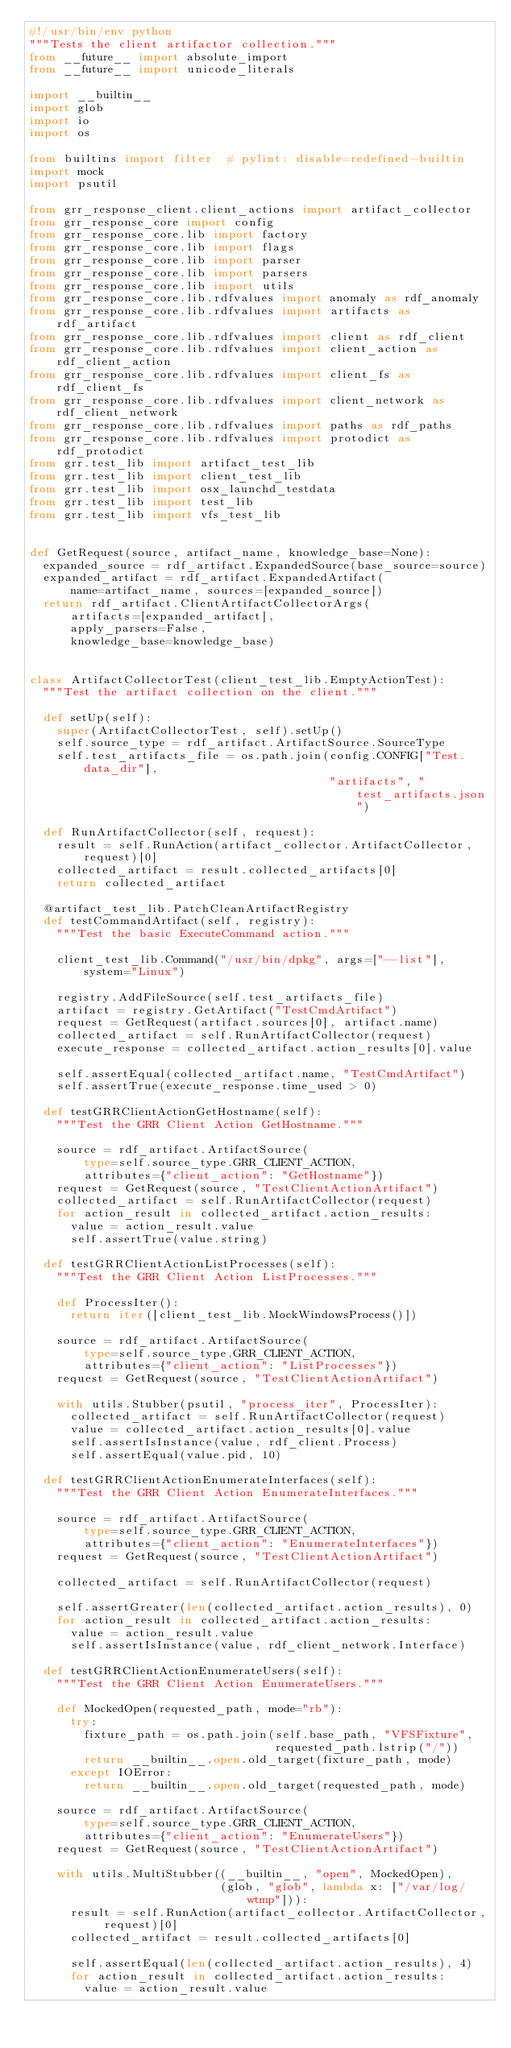Convert code to text. <code><loc_0><loc_0><loc_500><loc_500><_Python_>#!/usr/bin/env python
"""Tests the client artifactor collection."""
from __future__ import absolute_import
from __future__ import unicode_literals

import __builtin__
import glob
import io
import os

from builtins import filter  # pylint: disable=redefined-builtin
import mock
import psutil

from grr_response_client.client_actions import artifact_collector
from grr_response_core import config
from grr_response_core.lib import factory
from grr_response_core.lib import flags
from grr_response_core.lib import parser
from grr_response_core.lib import parsers
from grr_response_core.lib import utils
from grr_response_core.lib.rdfvalues import anomaly as rdf_anomaly
from grr_response_core.lib.rdfvalues import artifacts as rdf_artifact
from grr_response_core.lib.rdfvalues import client as rdf_client
from grr_response_core.lib.rdfvalues import client_action as rdf_client_action
from grr_response_core.lib.rdfvalues import client_fs as rdf_client_fs
from grr_response_core.lib.rdfvalues import client_network as rdf_client_network
from grr_response_core.lib.rdfvalues import paths as rdf_paths
from grr_response_core.lib.rdfvalues import protodict as rdf_protodict
from grr.test_lib import artifact_test_lib
from grr.test_lib import client_test_lib
from grr.test_lib import osx_launchd_testdata
from grr.test_lib import test_lib
from grr.test_lib import vfs_test_lib


def GetRequest(source, artifact_name, knowledge_base=None):
  expanded_source = rdf_artifact.ExpandedSource(base_source=source)
  expanded_artifact = rdf_artifact.ExpandedArtifact(
      name=artifact_name, sources=[expanded_source])
  return rdf_artifact.ClientArtifactCollectorArgs(
      artifacts=[expanded_artifact],
      apply_parsers=False,
      knowledge_base=knowledge_base)


class ArtifactCollectorTest(client_test_lib.EmptyActionTest):
  """Test the artifact collection on the client."""

  def setUp(self):
    super(ArtifactCollectorTest, self).setUp()
    self.source_type = rdf_artifact.ArtifactSource.SourceType
    self.test_artifacts_file = os.path.join(config.CONFIG["Test.data_dir"],
                                            "artifacts", "test_artifacts.json")

  def RunArtifactCollector(self, request):
    result = self.RunAction(artifact_collector.ArtifactCollector, request)[0]
    collected_artifact = result.collected_artifacts[0]
    return collected_artifact

  @artifact_test_lib.PatchCleanArtifactRegistry
  def testCommandArtifact(self, registry):
    """Test the basic ExecuteCommand action."""

    client_test_lib.Command("/usr/bin/dpkg", args=["--list"], system="Linux")

    registry.AddFileSource(self.test_artifacts_file)
    artifact = registry.GetArtifact("TestCmdArtifact")
    request = GetRequest(artifact.sources[0], artifact.name)
    collected_artifact = self.RunArtifactCollector(request)
    execute_response = collected_artifact.action_results[0].value

    self.assertEqual(collected_artifact.name, "TestCmdArtifact")
    self.assertTrue(execute_response.time_used > 0)

  def testGRRClientActionGetHostname(self):
    """Test the GRR Client Action GetHostname."""

    source = rdf_artifact.ArtifactSource(
        type=self.source_type.GRR_CLIENT_ACTION,
        attributes={"client_action": "GetHostname"})
    request = GetRequest(source, "TestClientActionArtifact")
    collected_artifact = self.RunArtifactCollector(request)
    for action_result in collected_artifact.action_results:
      value = action_result.value
      self.assertTrue(value.string)

  def testGRRClientActionListProcesses(self):
    """Test the GRR Client Action ListProcesses."""

    def ProcessIter():
      return iter([client_test_lib.MockWindowsProcess()])

    source = rdf_artifact.ArtifactSource(
        type=self.source_type.GRR_CLIENT_ACTION,
        attributes={"client_action": "ListProcesses"})
    request = GetRequest(source, "TestClientActionArtifact")

    with utils.Stubber(psutil, "process_iter", ProcessIter):
      collected_artifact = self.RunArtifactCollector(request)
      value = collected_artifact.action_results[0].value
      self.assertIsInstance(value, rdf_client.Process)
      self.assertEqual(value.pid, 10)

  def testGRRClientActionEnumerateInterfaces(self):
    """Test the GRR Client Action EnumerateInterfaces."""

    source = rdf_artifact.ArtifactSource(
        type=self.source_type.GRR_CLIENT_ACTION,
        attributes={"client_action": "EnumerateInterfaces"})
    request = GetRequest(source, "TestClientActionArtifact")

    collected_artifact = self.RunArtifactCollector(request)

    self.assertGreater(len(collected_artifact.action_results), 0)
    for action_result in collected_artifact.action_results:
      value = action_result.value
      self.assertIsInstance(value, rdf_client_network.Interface)

  def testGRRClientActionEnumerateUsers(self):
    """Test the GRR Client Action EnumerateUsers."""

    def MockedOpen(requested_path, mode="rb"):
      try:
        fixture_path = os.path.join(self.base_path, "VFSFixture",
                                    requested_path.lstrip("/"))
        return __builtin__.open.old_target(fixture_path, mode)
      except IOError:
        return __builtin__.open.old_target(requested_path, mode)

    source = rdf_artifact.ArtifactSource(
        type=self.source_type.GRR_CLIENT_ACTION,
        attributes={"client_action": "EnumerateUsers"})
    request = GetRequest(source, "TestClientActionArtifact")

    with utils.MultiStubber((__builtin__, "open", MockedOpen),
                            (glob, "glob", lambda x: ["/var/log/wtmp"])):
      result = self.RunAction(artifact_collector.ArtifactCollector, request)[0]
      collected_artifact = result.collected_artifacts[0]

      self.assertEqual(len(collected_artifact.action_results), 4)
      for action_result in collected_artifact.action_results:
        value = action_result.value</code> 